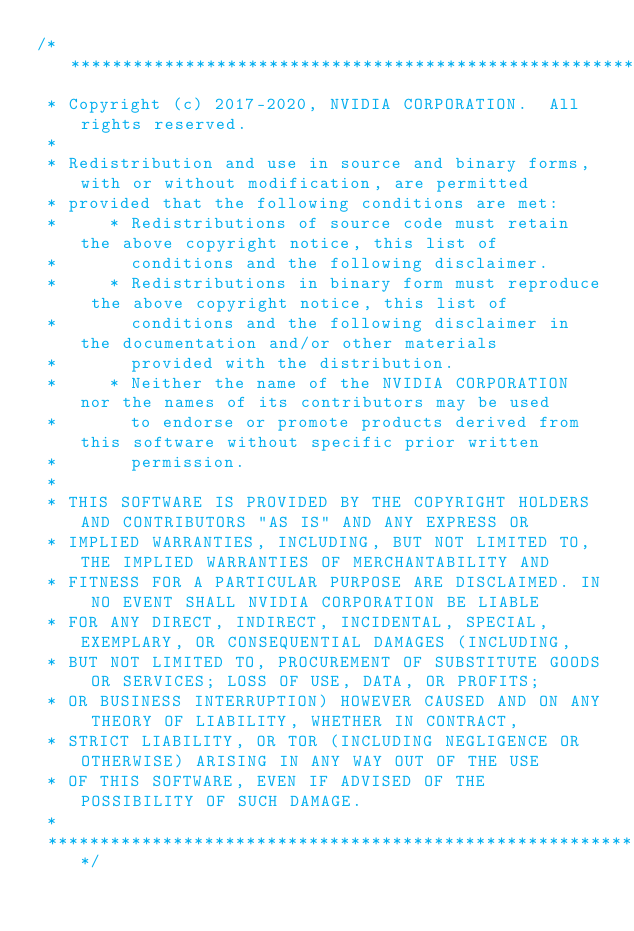Convert code to text. <code><loc_0><loc_0><loc_500><loc_500><_Cuda_>/***************************************************************************************************
 * Copyright (c) 2017-2020, NVIDIA CORPORATION.  All rights reserved.
 *
 * Redistribution and use in source and binary forms, with or without modification, are permitted
 * provided that the following conditions are met:
 *     * Redistributions of source code must retain the above copyright notice, this list of
 *       conditions and the following disclaimer.
 *     * Redistributions in binary form must reproduce the above copyright notice, this list of
 *       conditions and the following disclaimer in the documentation and/or other materials
 *       provided with the distribution.
 *     * Neither the name of the NVIDIA CORPORATION nor the names of its contributors may be used
 *       to endorse or promote products derived from this software without specific prior written
 *       permission.
 *
 * THIS SOFTWARE IS PROVIDED BY THE COPYRIGHT HOLDERS AND CONTRIBUTORS "AS IS" AND ANY EXPRESS OR
 * IMPLIED WARRANTIES, INCLUDING, BUT NOT LIMITED TO, THE IMPLIED WARRANTIES OF MERCHANTABILITY AND
 * FITNESS FOR A PARTICULAR PURPOSE ARE DISCLAIMED. IN NO EVENT SHALL NVIDIA CORPORATION BE LIABLE
 * FOR ANY DIRECT, INDIRECT, INCIDENTAL, SPECIAL, EXEMPLARY, OR CONSEQUENTIAL DAMAGES (INCLUDING,
 * BUT NOT LIMITED TO, PROCUREMENT OF SUBSTITUTE GOODS OR SERVICES; LOSS OF USE, DATA, OR PROFITS;
 * OR BUSINESS INTERRUPTION) HOWEVER CAUSED AND ON ANY THEORY OF LIABILITY, WHETHER IN CONTRACT,
 * STRICT LIABILITY, OR TOR (INCLUDING NEGLIGENCE OR OTHERWISE) ARISING IN ANY WAY OUT OF THE USE
 * OF THIS SOFTWARE, EVEN IF ADVISED OF THE POSSIBILITY OF SUCH DAMAGE.
 *
 **************************************************************************************************/</code> 